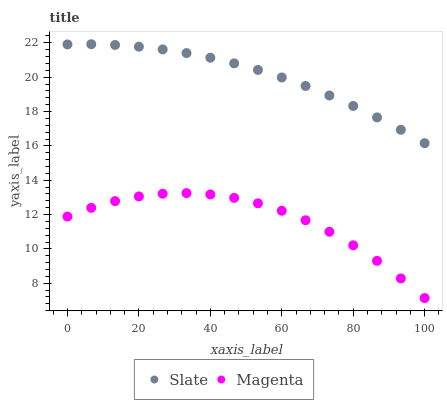Does Magenta have the minimum area under the curve?
Answer yes or no. Yes. Does Slate have the maximum area under the curve?
Answer yes or no. Yes. Does Magenta have the maximum area under the curve?
Answer yes or no. No. Is Slate the smoothest?
Answer yes or no. Yes. Is Magenta the roughest?
Answer yes or no. Yes. Is Magenta the smoothest?
Answer yes or no. No. Does Magenta have the lowest value?
Answer yes or no. Yes. Does Slate have the highest value?
Answer yes or no. Yes. Does Magenta have the highest value?
Answer yes or no. No. Is Magenta less than Slate?
Answer yes or no. Yes. Is Slate greater than Magenta?
Answer yes or no. Yes. Does Magenta intersect Slate?
Answer yes or no. No. 